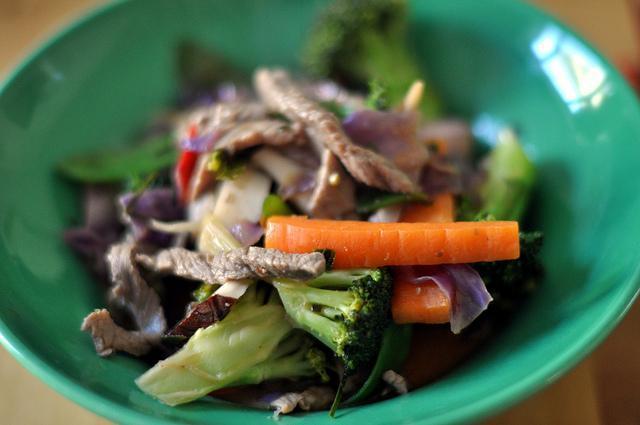How many broccolis are there?
Give a very brief answer. 4. How many carrots are visible?
Give a very brief answer. 2. 